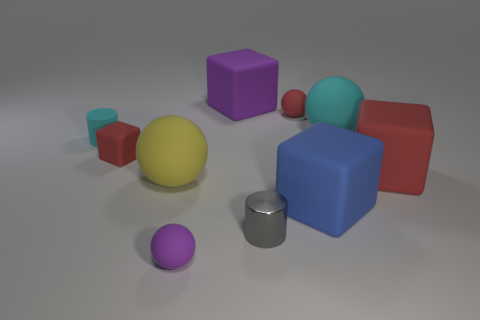Are there any other things that are made of the same material as the small gray cylinder?
Your answer should be compact. No. Is the shape of the tiny red thing in front of the small cyan object the same as the purple rubber object in front of the yellow rubber object?
Your answer should be compact. No. Do the gray thing and the cyan object that is left of the purple matte sphere have the same size?
Ensure brevity in your answer.  Yes. Are there more big red metal cubes than yellow rubber balls?
Give a very brief answer. No. Do the yellow ball that is to the left of the large red thing and the small cylinder that is left of the purple matte sphere have the same material?
Make the answer very short. Yes. What is the red sphere made of?
Your answer should be very brief. Rubber. Is the number of shiny cylinders behind the large yellow rubber sphere greater than the number of big yellow matte things?
Offer a terse response. No. There is a tiny cylinder right of the purple matte thing that is behind the small gray thing; how many gray things are behind it?
Keep it short and to the point. 0. There is a small object that is both on the right side of the big purple matte block and in front of the matte cylinder; what is its material?
Your answer should be very brief. Metal. The rubber cylinder has what color?
Your answer should be very brief. Cyan. 